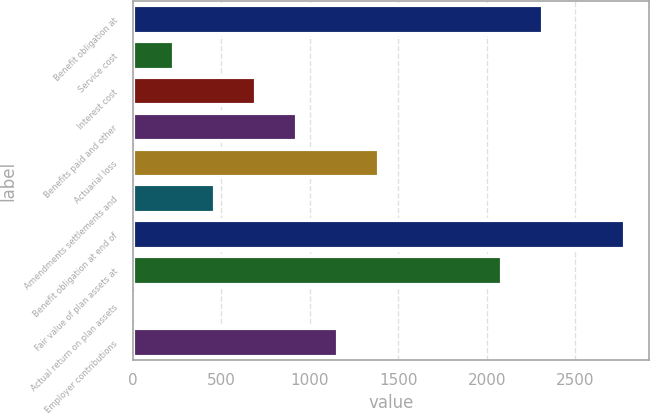Convert chart to OTSL. <chart><loc_0><loc_0><loc_500><loc_500><bar_chart><fcel>Benefit obligation at<fcel>Service cost<fcel>Interest cost<fcel>Benefits paid and other<fcel>Actuarial loss<fcel>Amendments settlements and<fcel>Benefit obligation at end of<fcel>Fair value of plan assets at<fcel>Actual return on plan assets<fcel>Employer contributions<nl><fcel>2316.1<fcel>232.24<fcel>695.32<fcel>926.86<fcel>1389.94<fcel>463.78<fcel>2779.18<fcel>2084.56<fcel>0.7<fcel>1158.4<nl></chart> 